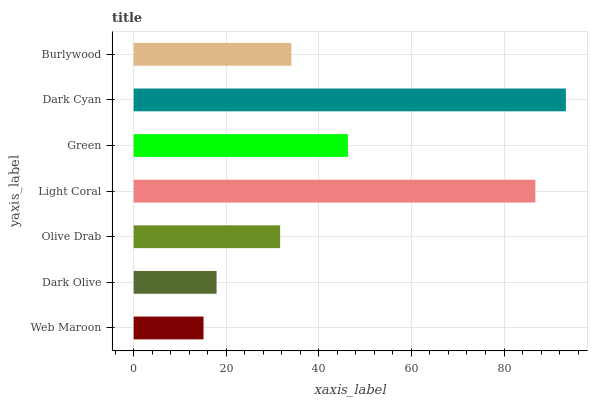Is Web Maroon the minimum?
Answer yes or no. Yes. Is Dark Cyan the maximum?
Answer yes or no. Yes. Is Dark Olive the minimum?
Answer yes or no. No. Is Dark Olive the maximum?
Answer yes or no. No. Is Dark Olive greater than Web Maroon?
Answer yes or no. Yes. Is Web Maroon less than Dark Olive?
Answer yes or no. Yes. Is Web Maroon greater than Dark Olive?
Answer yes or no. No. Is Dark Olive less than Web Maroon?
Answer yes or no. No. Is Burlywood the high median?
Answer yes or no. Yes. Is Burlywood the low median?
Answer yes or no. Yes. Is Dark Olive the high median?
Answer yes or no. No. Is Dark Cyan the low median?
Answer yes or no. No. 